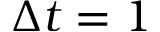<formula> <loc_0><loc_0><loc_500><loc_500>\Delta t = 1</formula> 